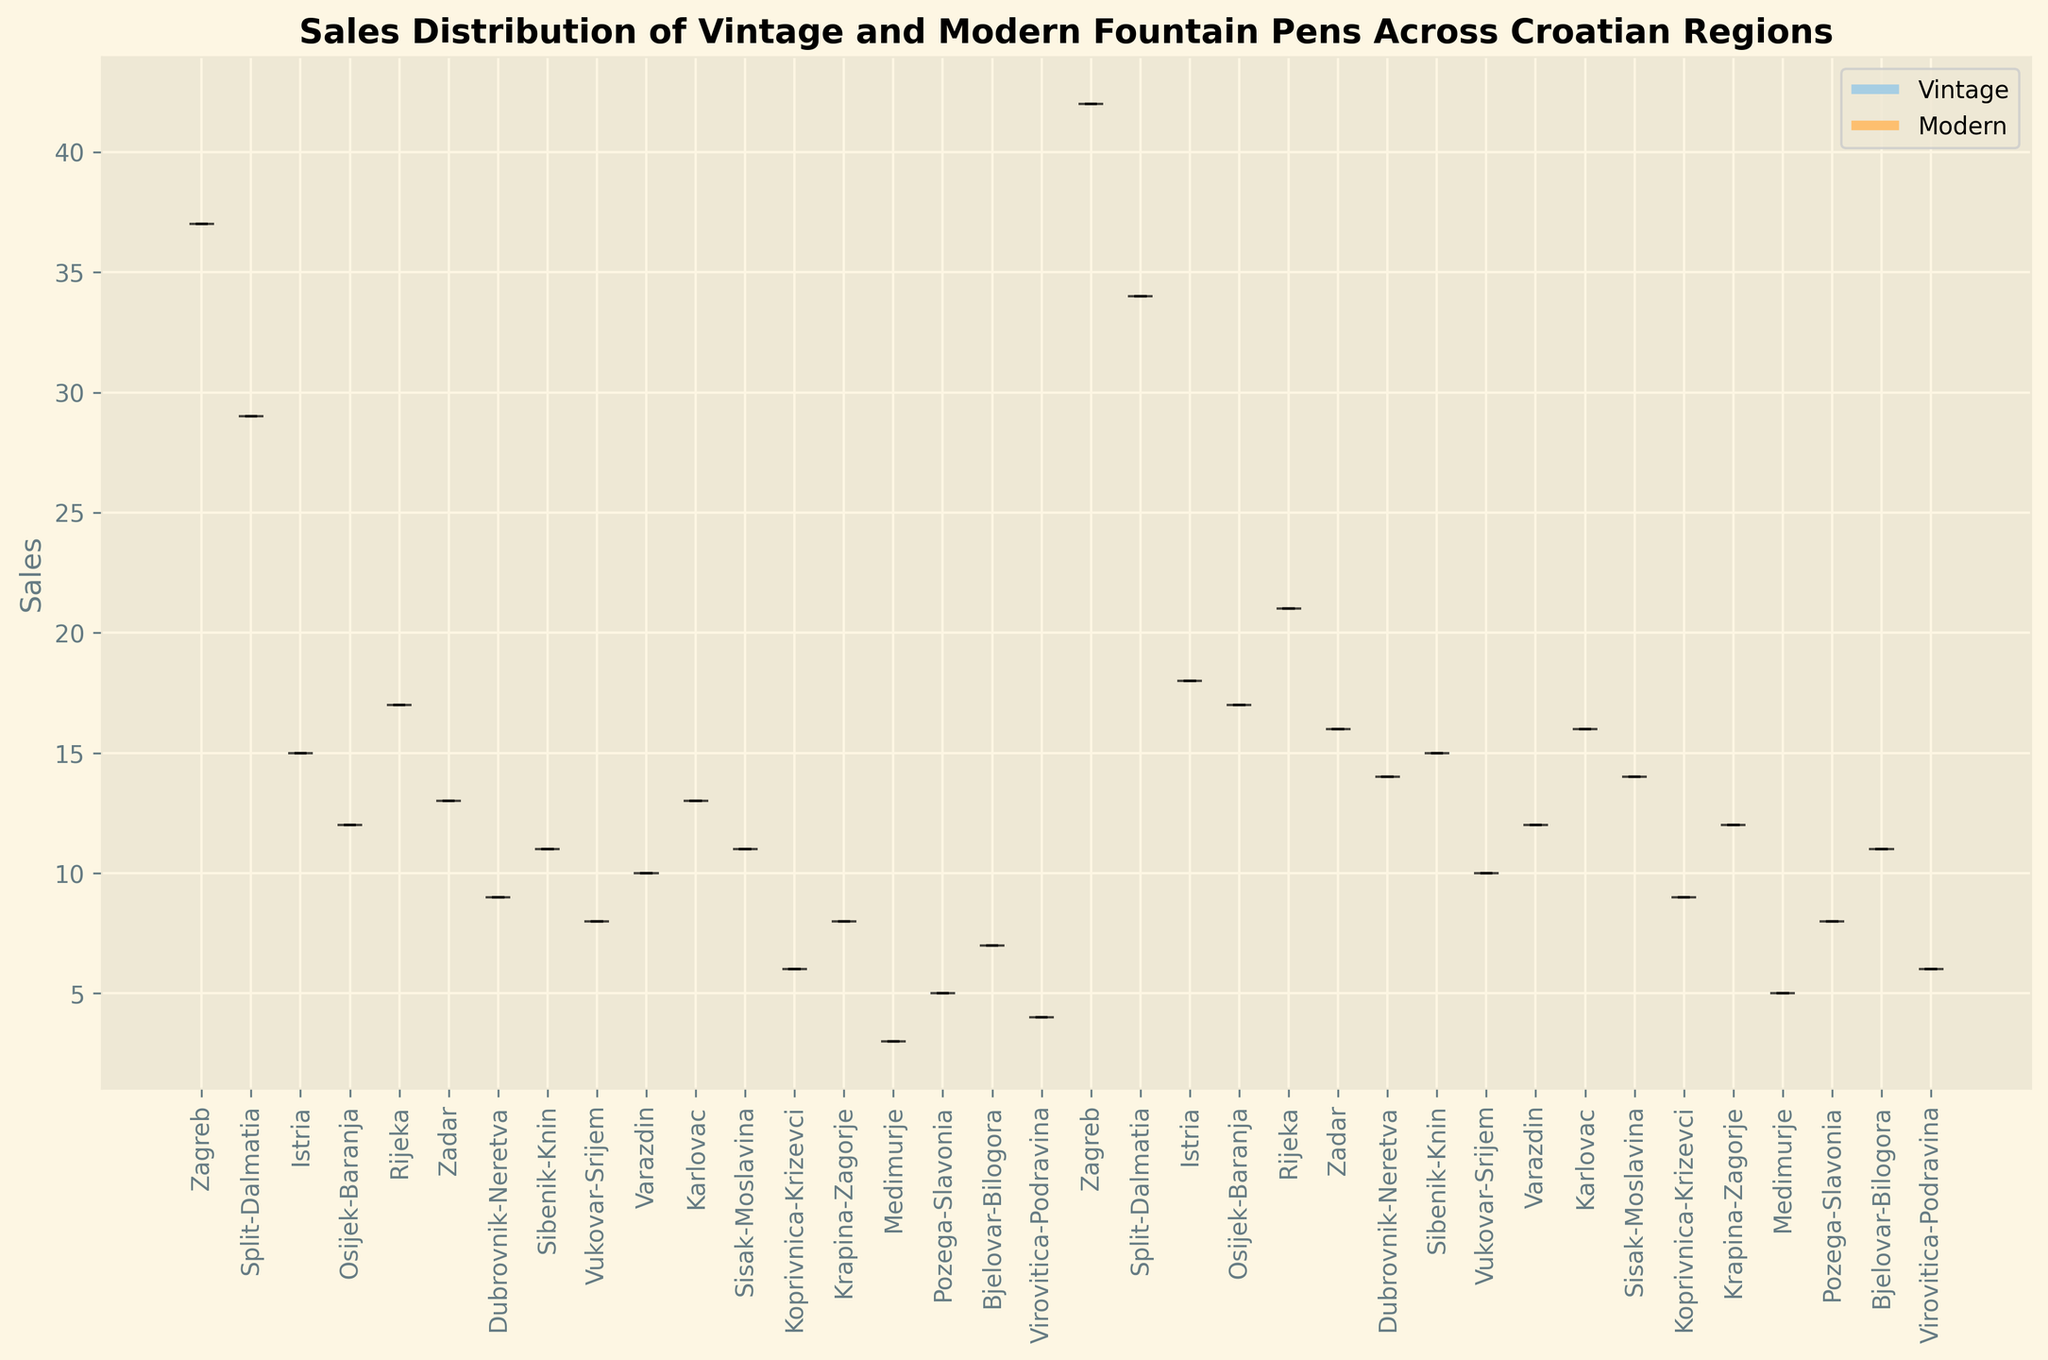Which region has the highest median sales for vintage fountain pens? To identify this, locate the median markers on the violin plots for vintage pens for each region and compare their positions. Zagreb has the highest median sales as its median marker is higher compared to other regions.
Answer: Zagreb Which region shows the greatest difference in median sales between vintage and modern pens? To determine this, compare the median markers of vintage and modern pens for each region. The region with the greatest distance between the two markers demonstrates the largest difference. Zagreb has the greatest difference as the markers for vintage and modern pens are more distinctly apart.
Answer: Zagreb In which region are the sales distributions of vintage and modern pens most similar? Evaluate the violin plots to see where the shapes and spread of the sales distributions are the closest for vintage and modern pens. Sibenik-Knin shows very similar distributions for both pen types.
Answer: Sibenik-Knin What is the median sales value of modern pens in Split-Dalmatia? Locate the median marker on the violin plot for modern pens in Split-Dalmatia. The median sales value is visible at the point where the horizontal line intersects the plot.
Answer: 34 Is the spread of sales for vintage pens wider or narrower than modern pens in Zagreb? Compare the width of the violin plots for vintage and modern pens in Zagreb to determine which is wider or narrower. The vintage pen sales distribution appears wider, indicating more variability in sales.
Answer: Wider Which type of pen has a generally higher median sales value across most regions? Compare the median markers for vintage and modern pens across all regions, noting which type more frequently has higher markers. Modern pens typically have higher median sales values across most regions.
Answer: Modern pens Which region shows the narrowest sales distribution for modern pens? Identify the modern pen violin plot with the narrowest shape, indicating less variability in sales. Medimurje has the narrowest sales distribution for modern pens.
Answer: Medimurje How do the sales distributions of vintage pens in Rijeka and Zadar compare visually? Examine the violin plots for vintage pens in Rijeka and Zadar to compare the shapes and spread. Both regions show similarly shaped distributions but Rijeka's distribution is slightly wider and higher.
Answer: Similar, but Rijeka is slightly wider and higher How is the color used to represent vintage and modern pens in the plot? Notice the differences in colors used for the violin plots. Vintage pens are represented with one set of colors, while modern pens are represented with a different set from the same palette. Each pen type has distinct colors derived from a single colormap.
Answer: Vintage and modern pens are represented by different colors from the colormap "Paired" Which regions have the lowest median sales for vintage pens? Identify regions where the median markers for vintage pens are at their lowest points. Vukovar-Srijem and Medimurje have the lowest median sales for vintage pens.
Answer: Vukovar-Srijem, Medimurje 